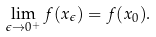Convert formula to latex. <formula><loc_0><loc_0><loc_500><loc_500>\lim _ { \epsilon \to 0 ^ { + } } f ( x _ { \epsilon } ) = f ( x _ { 0 } ) .</formula> 